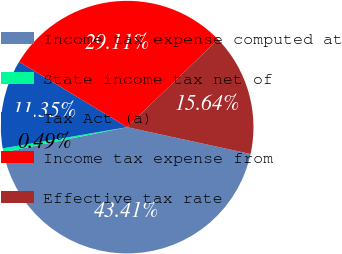<chart> <loc_0><loc_0><loc_500><loc_500><pie_chart><fcel>Income tax expense computed at<fcel>State income tax net of<fcel>Tax Act (a)<fcel>Income tax expense from<fcel>Effective tax rate<nl><fcel>43.41%<fcel>0.49%<fcel>11.35%<fcel>29.11%<fcel>15.64%<nl></chart> 